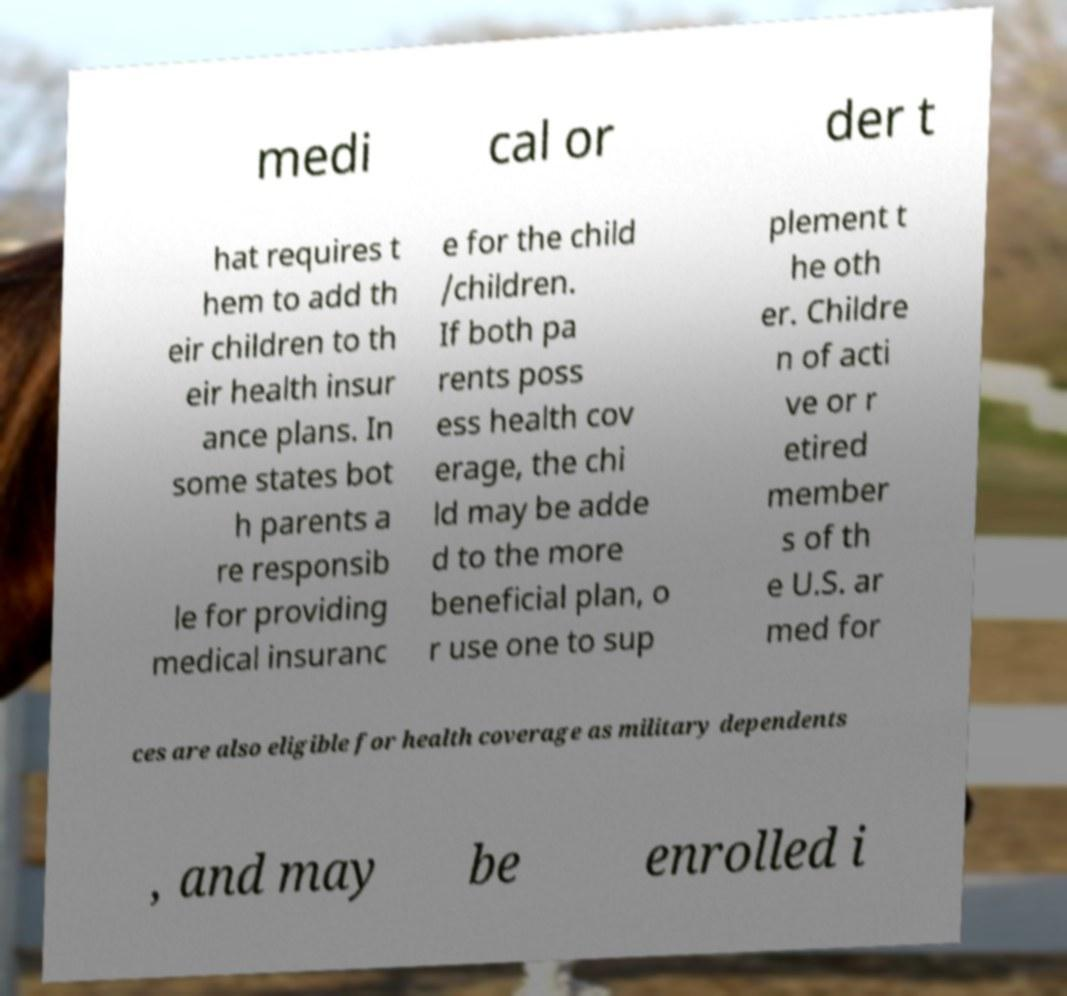Could you extract and type out the text from this image? medi cal or der t hat requires t hem to add th eir children to th eir health insur ance plans. In some states bot h parents a re responsib le for providing medical insuranc e for the child /children. If both pa rents poss ess health cov erage, the chi ld may be adde d to the more beneficial plan, o r use one to sup plement t he oth er. Childre n of acti ve or r etired member s of th e U.S. ar med for ces are also eligible for health coverage as military dependents , and may be enrolled i 